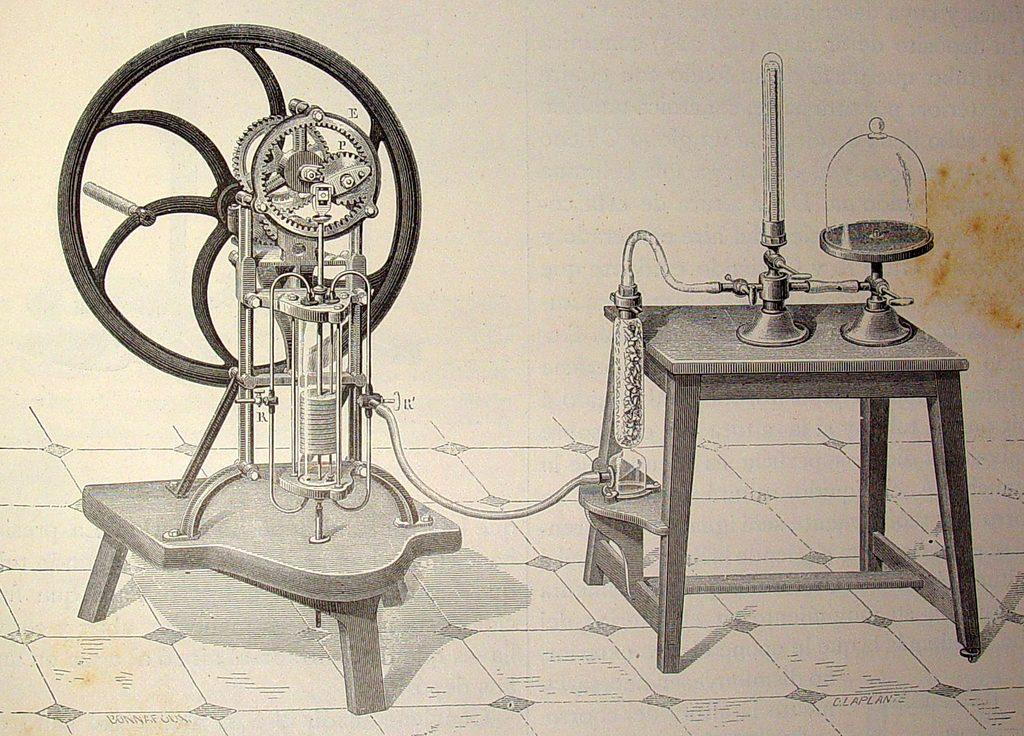How many tables are present in the image? There are two tables in the image. What can be found on the first table? On one table, there are two test tubes and a flask. What is located on the second table? On the other table, there is a wheel and gears. What type of flooring is visible in the image? The floor has tiles. What advice does the achiever give to the visitor in the image? There is no achiever or visitor present in the image; it features two tables with various objects. 